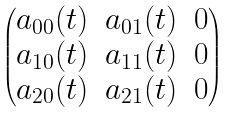Convert formula to latex. <formula><loc_0><loc_0><loc_500><loc_500>\begin{pmatrix} a _ { 0 0 } ( t ) & a _ { 0 1 } ( t ) & 0 \\ a _ { 1 0 } ( t ) & a _ { 1 1 } ( t ) & 0 \\ a _ { 2 0 } ( t ) & a _ { 2 1 } ( t ) & 0 \end{pmatrix}</formula> 